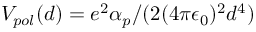Convert formula to latex. <formula><loc_0><loc_0><loc_500><loc_500>V _ { p o l } ( d ) = e ^ { 2 } \alpha _ { p } / ( 2 ( 4 \pi \epsilon _ { 0 } ) ^ { 2 } d ^ { 4 } )</formula> 